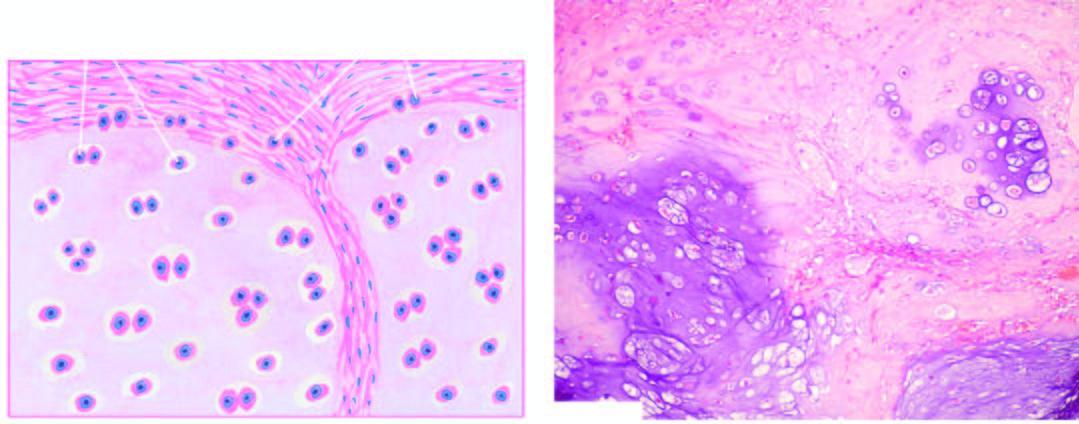do histologic features include invasion of the tumour into adjacent soft tissues and cytologic characteristics of malignancy in the tumour cells?
Answer the question using a single word or phrase. Yes 